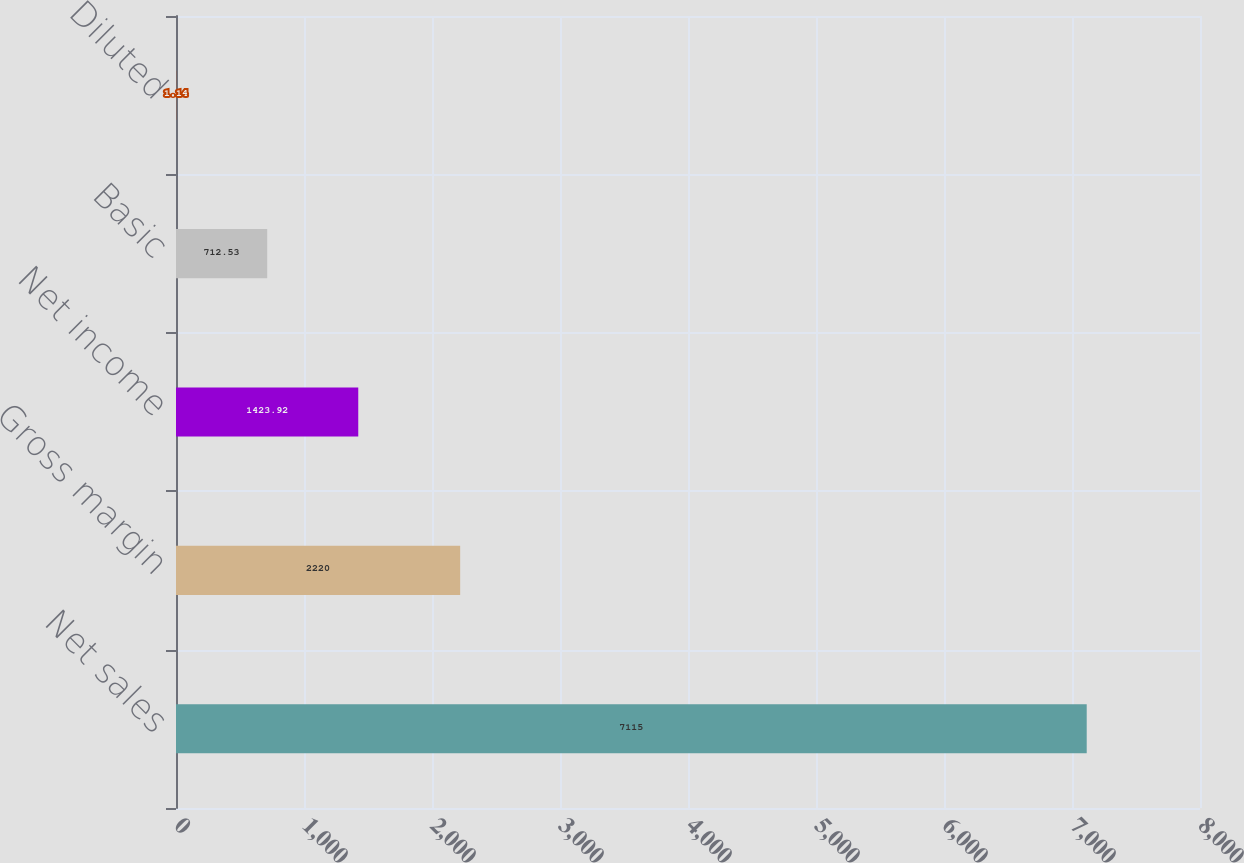<chart> <loc_0><loc_0><loc_500><loc_500><bar_chart><fcel>Net sales<fcel>Gross margin<fcel>Net income<fcel>Basic<fcel>Diluted<nl><fcel>7115<fcel>2220<fcel>1423.92<fcel>712.53<fcel>1.14<nl></chart> 